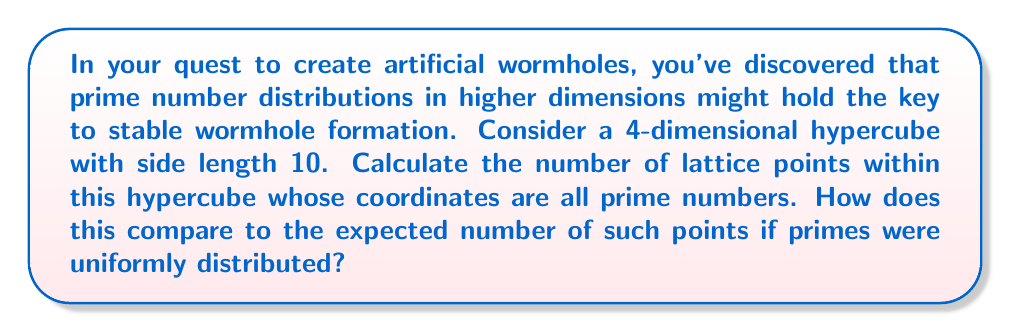Could you help me with this problem? Let's approach this step-by-step:

1) First, we need to identify the prime numbers less than or equal to 10:
   2, 3, 5, 7

2) In a 4-dimensional hypercube, each point has 4 coordinates. We need to count how many ways we can select 4 primes from our list, with replacement.

3) This is equivalent to finding the number of ways to arrange 4 items, where each item can be one of 4 choices. This is a case of combinations with repetition.

4) The formula for this is:
   $$ \binom{n+r-1}{r} $$
   where n is the number of choices (4 primes) and r is the number of selections (4 dimensions).

5) Plugging in our values:
   $$ \binom{4+4-1}{4} = \binom{7}{4} = \frac{7!}{4!(7-4)!} = \frac{7 \cdot 6 \cdot 5 \cdot 4}{4 \cdot 3 \cdot 2 \cdot 1} = 35 $$

6) Now, for the comparison with uniform distribution:
   - Total lattice points in the hypercube: $10^4 = 10000$
   - Probability of a number being prime in [1,10]: $4/10 = 0.4$
   - Expected number of points if primes were uniform: $10000 \cdot 0.4^4 = 256$

7) The ratio of actual to expected:
   $$ \frac{35}{256} \approx 0.137 $$

This shows that prime numbers cluster less in higher dimensions than would be expected from a uniform distribution.
Answer: 35 points; ratio to uniform expectation ≈ 0.137 